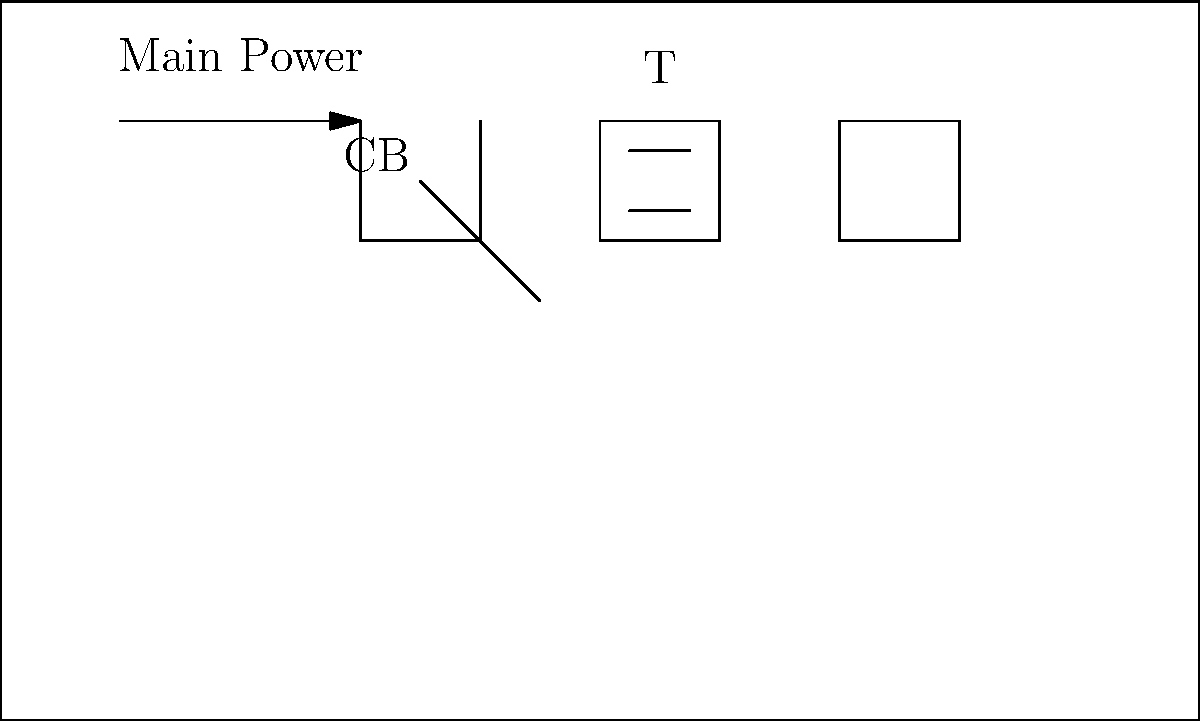In the given schematic of a subway train's electrical system, identify the potential safety hazard and explain its implications for the system's operation. To identify the potential safety hazard in this subway train's electrical system schematic, let's analyze the components and their connections:

1. The system starts with the main power supply, which is connected to a circuit breaker (CB).
2. The circuit breaker is then connected to a transformer (T).
3. The transformer is linked to a motor (M).
4. The motor is grounded.

The potential safety hazard is indicated by the red dot between the transformer and the motor. This could represent several issues:

1. Exposed wiring: If the wiring between the transformer and motor is exposed, it poses a significant electrocution risk.
2. Loose connection: A loose connection can cause arcing, leading to overheating and potential fire hazards.
3. Insulation breakdown: Degraded insulation can result in short circuits or electrical leakage.

Implications for the system's operation:

1. Safety risks: The hazard could pose immediate danger to maintenance personnel or passengers if left unaddressed.
2. System reliability: Electrical issues can cause unexpected system shutdowns or malfunctions, disrupting service.
3. Energy efficiency: Problems in the electrical system can lead to increased power consumption and reduced efficiency.
4. Equipment damage: Prolonged exposure to electrical faults can damage expensive components like the motor or transformer.
5. Regulatory compliance: Unresolved safety hazards may violate safety regulations and standards for subway systems.

As a subway engineer valuing safety, it's crucial to address this hazard promptly to ensure the system's safe and efficient operation.
Answer: Exposed wiring/loose connection between transformer and motor 